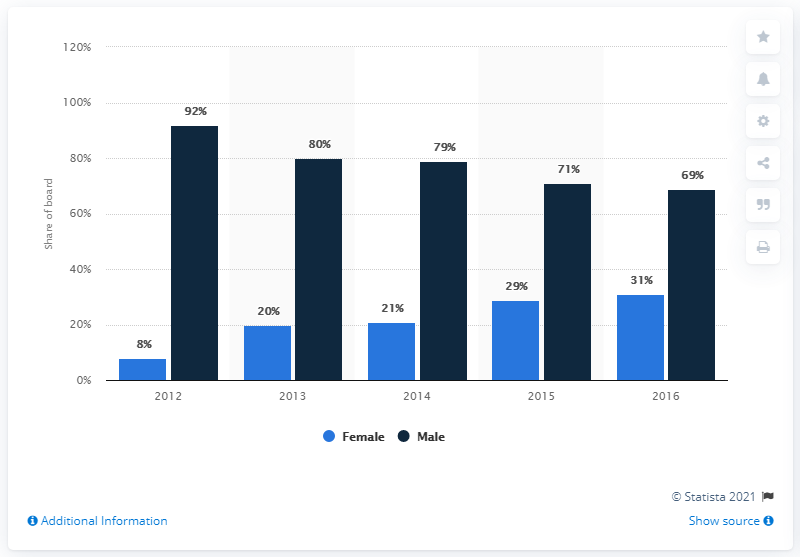List a handful of essential elements in this visual. By the end of 2016, 31% of the board of directors at the company were women. The Barclays Bank Group's board of directors has not met in the year 2012. 